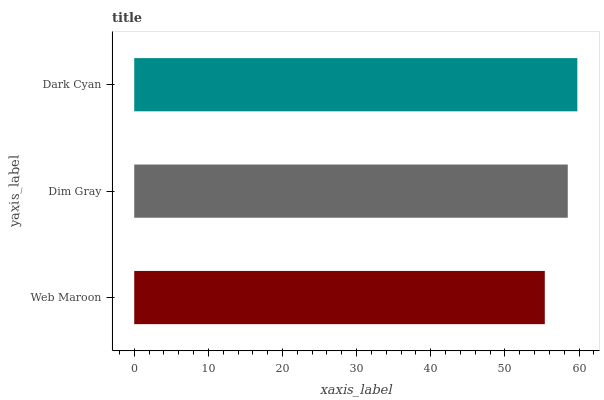Is Web Maroon the minimum?
Answer yes or no. Yes. Is Dark Cyan the maximum?
Answer yes or no. Yes. Is Dim Gray the minimum?
Answer yes or no. No. Is Dim Gray the maximum?
Answer yes or no. No. Is Dim Gray greater than Web Maroon?
Answer yes or no. Yes. Is Web Maroon less than Dim Gray?
Answer yes or no. Yes. Is Web Maroon greater than Dim Gray?
Answer yes or no. No. Is Dim Gray less than Web Maroon?
Answer yes or no. No. Is Dim Gray the high median?
Answer yes or no. Yes. Is Dim Gray the low median?
Answer yes or no. Yes. Is Dark Cyan the high median?
Answer yes or no. No. Is Web Maroon the low median?
Answer yes or no. No. 